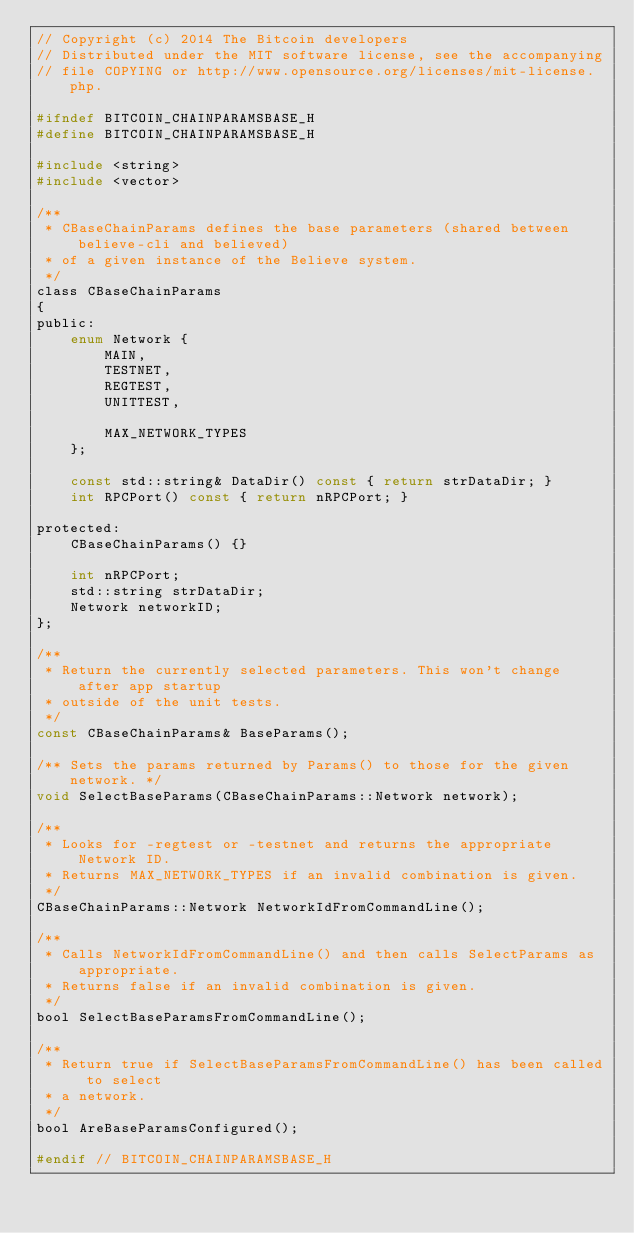Convert code to text. <code><loc_0><loc_0><loc_500><loc_500><_C_>// Copyright (c) 2014 The Bitcoin developers
// Distributed under the MIT software license, see the accompanying
// file COPYING or http://www.opensource.org/licenses/mit-license.php.

#ifndef BITCOIN_CHAINPARAMSBASE_H
#define BITCOIN_CHAINPARAMSBASE_H

#include <string>
#include <vector>

/**
 * CBaseChainParams defines the base parameters (shared between believe-cli and believed)
 * of a given instance of the Believe system.
 */
class CBaseChainParams
{
public:
    enum Network {
        MAIN,
        TESTNET,
        REGTEST,
        UNITTEST,

        MAX_NETWORK_TYPES
    };

    const std::string& DataDir() const { return strDataDir; }
    int RPCPort() const { return nRPCPort; }

protected:
    CBaseChainParams() {}

    int nRPCPort;
    std::string strDataDir;
    Network networkID;
};

/**
 * Return the currently selected parameters. This won't change after app startup
 * outside of the unit tests.
 */
const CBaseChainParams& BaseParams();

/** Sets the params returned by Params() to those for the given network. */
void SelectBaseParams(CBaseChainParams::Network network);

/**
 * Looks for -regtest or -testnet and returns the appropriate Network ID.
 * Returns MAX_NETWORK_TYPES if an invalid combination is given.
 */
CBaseChainParams::Network NetworkIdFromCommandLine();

/**
 * Calls NetworkIdFromCommandLine() and then calls SelectParams as appropriate.
 * Returns false if an invalid combination is given.
 */
bool SelectBaseParamsFromCommandLine();

/**
 * Return true if SelectBaseParamsFromCommandLine() has been called to select
 * a network.
 */
bool AreBaseParamsConfigured();

#endif // BITCOIN_CHAINPARAMSBASE_H
</code> 